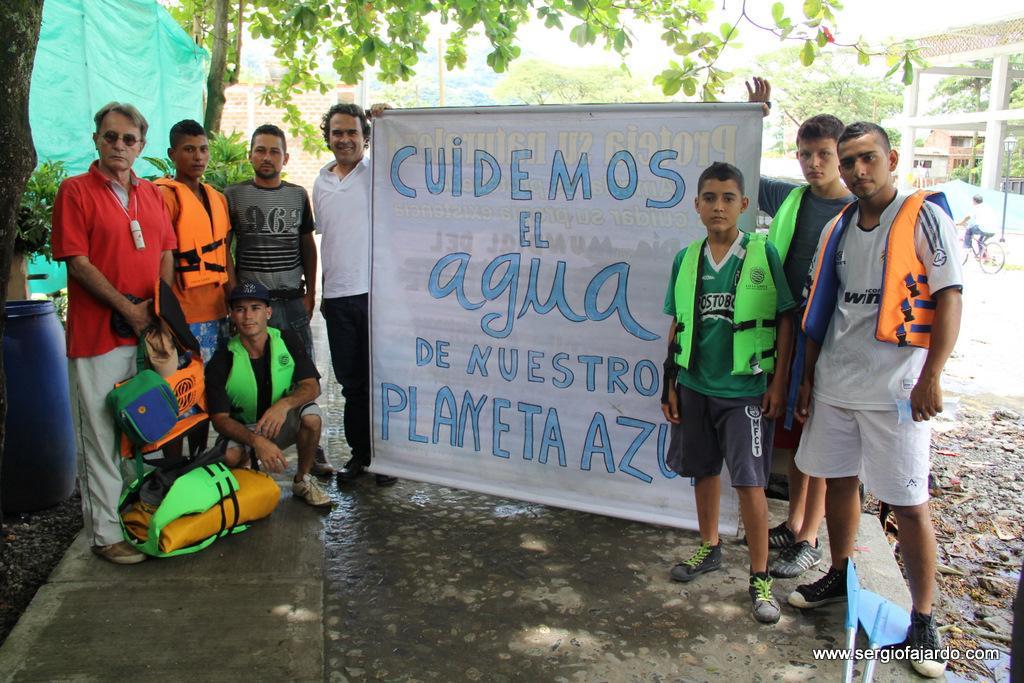Could you give a brief overview of what you see in this image? There are few people standing. Some are wearing jackets. Two persons are holding banner. In the back there are trees. On the right side there is a barrel. In the back there are buildings. 